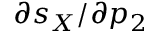Convert formula to latex. <formula><loc_0><loc_0><loc_500><loc_500>\partial s _ { X } / \partial p _ { 2 }</formula> 